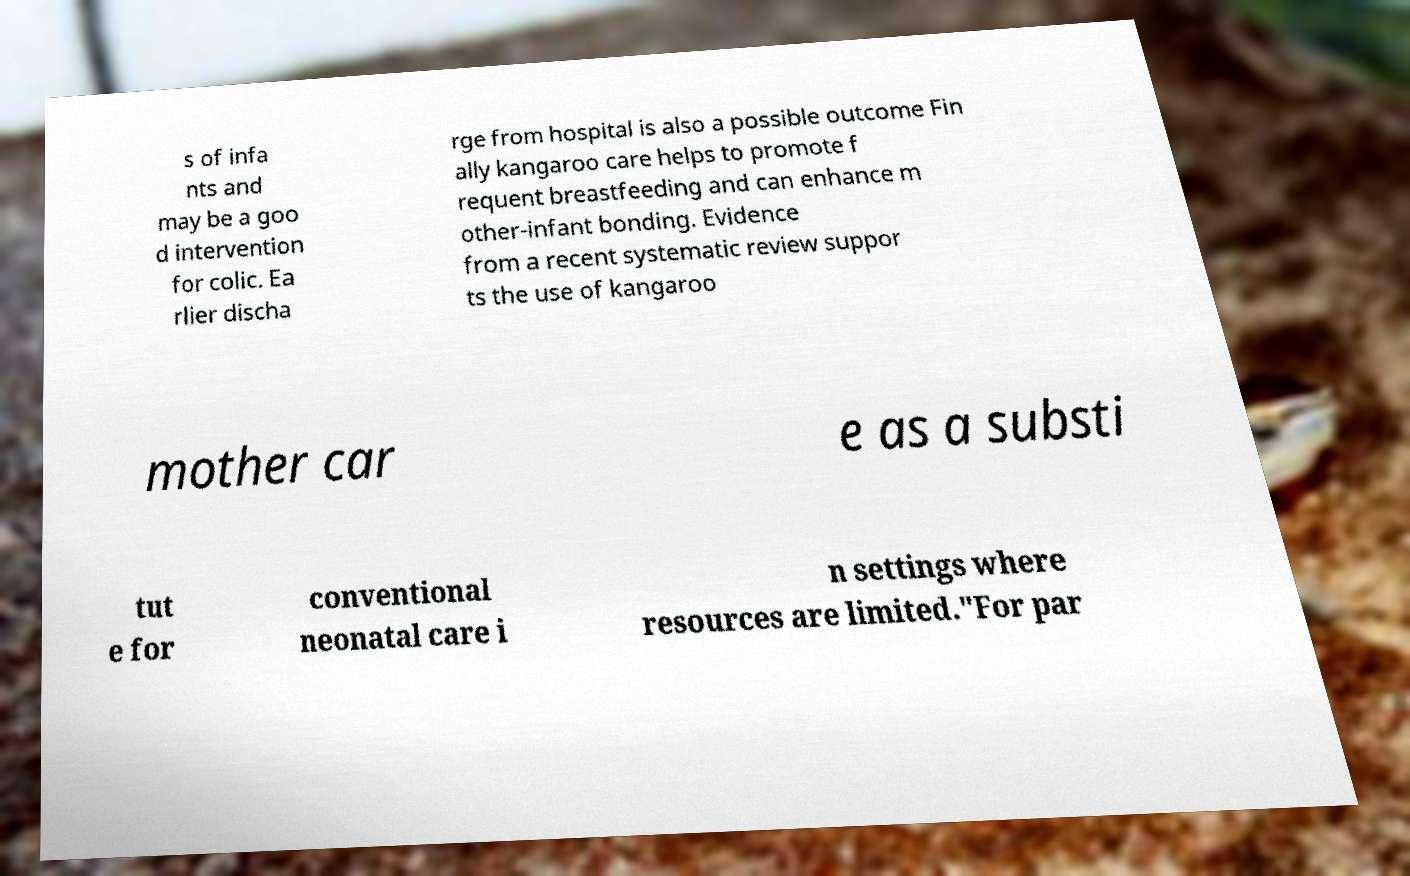I need the written content from this picture converted into text. Can you do that? s of infa nts and may be a goo d intervention for colic. Ea rlier discha rge from hospital is also a possible outcome Fin ally kangaroo care helps to promote f requent breastfeeding and can enhance m other-infant bonding. Evidence from a recent systematic review suppor ts the use of kangaroo mother car e as a substi tut e for conventional neonatal care i n settings where resources are limited."For par 